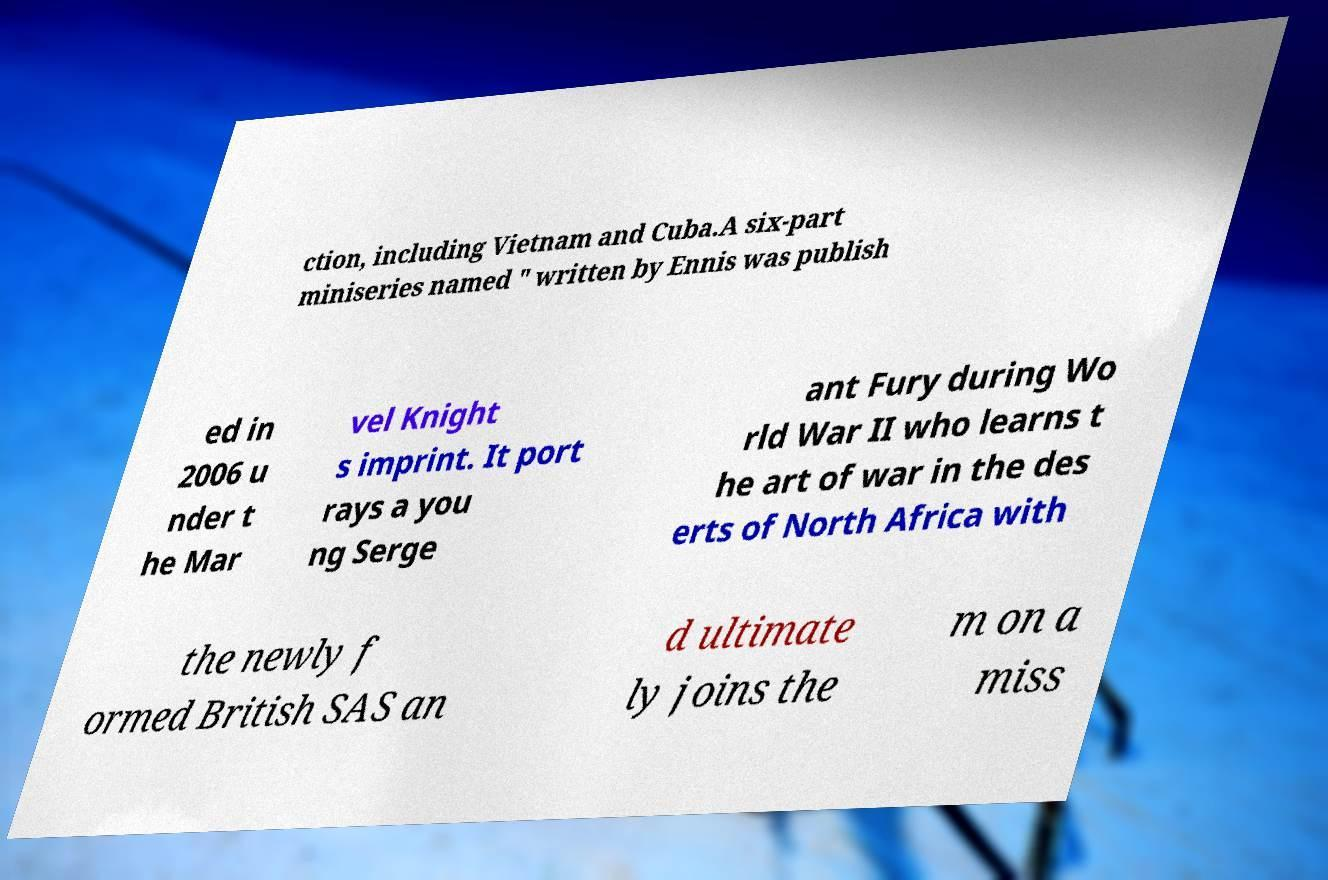Please identify and transcribe the text found in this image. ction, including Vietnam and Cuba.A six-part miniseries named " written by Ennis was publish ed in 2006 u nder t he Mar vel Knight s imprint. It port rays a you ng Serge ant Fury during Wo rld War II who learns t he art of war in the des erts of North Africa with the newly f ormed British SAS an d ultimate ly joins the m on a miss 